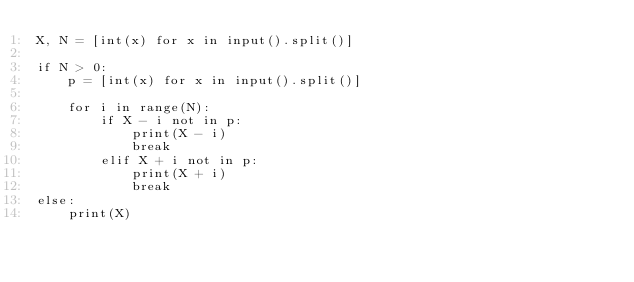<code> <loc_0><loc_0><loc_500><loc_500><_Python_>X, N = [int(x) for x in input().split()]

if N > 0:
    p = [int(x) for x in input().split()]

    for i in range(N):
        if X - i not in p:
            print(X - i)
            break
        elif X + i not in p:
            print(X + i)
            break
else:
    print(X)
</code> 